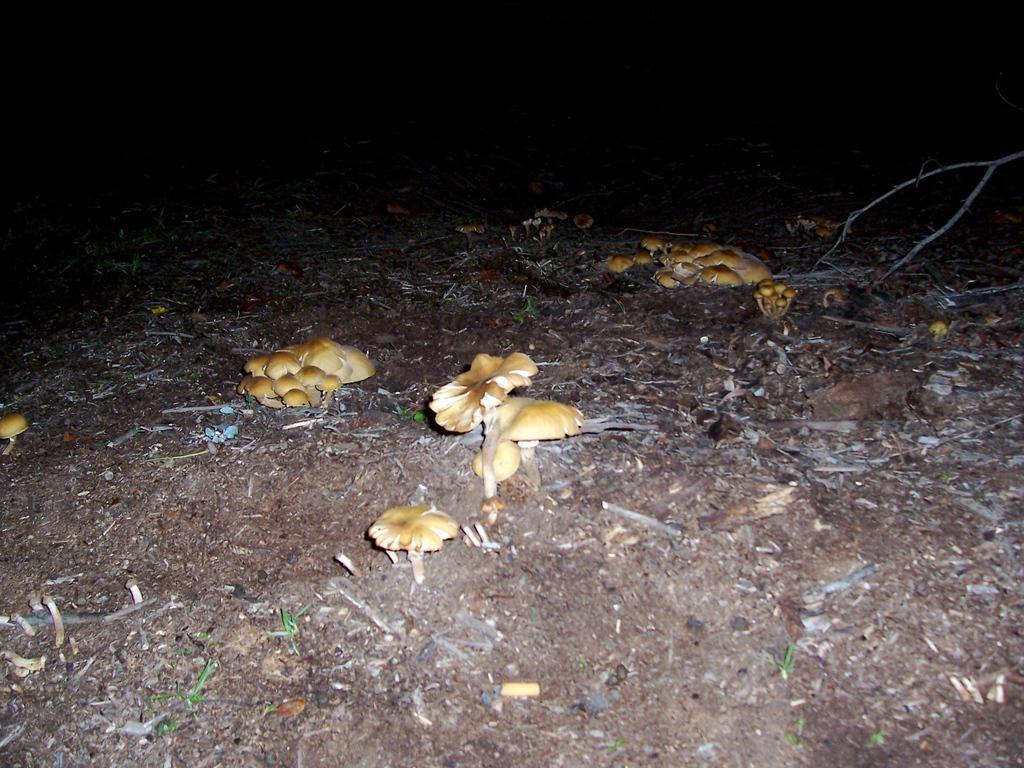How would you summarize this image in a sentence or two? In this image I see the ground on which there are mushrooms which are of brown in color and it is dark in the background and I see stocks over here. 